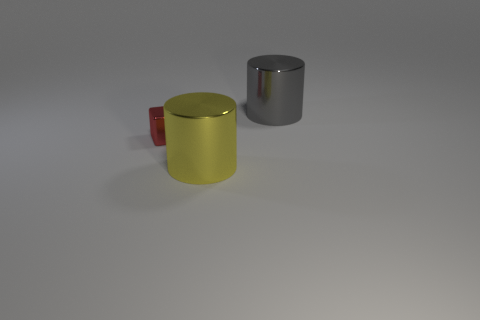Add 2 large red matte cylinders. How many objects exist? 5 Subtract all cylinders. How many objects are left? 1 Subtract all tiny cubes. Subtract all large gray metallic cylinders. How many objects are left? 1 Add 1 gray cylinders. How many gray cylinders are left? 2 Add 2 tiny gray things. How many tiny gray things exist? 2 Subtract 1 red cubes. How many objects are left? 2 Subtract 2 cylinders. How many cylinders are left? 0 Subtract all gray cylinders. Subtract all yellow blocks. How many cylinders are left? 1 Subtract all blue cylinders. How many gray cubes are left? 0 